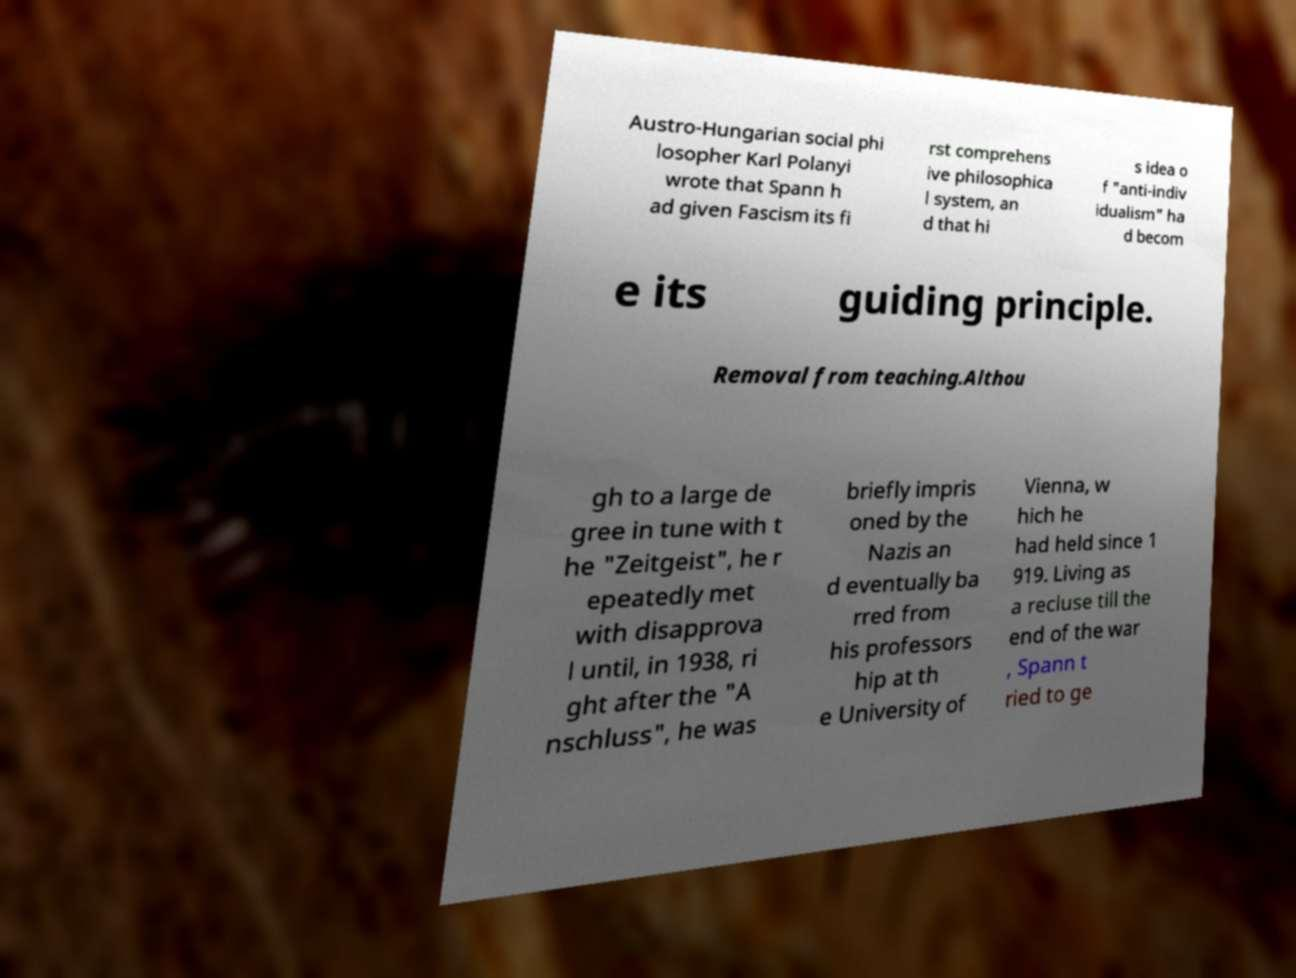There's text embedded in this image that I need extracted. Can you transcribe it verbatim? Austro-Hungarian social phi losopher Karl Polanyi wrote that Spann h ad given Fascism its fi rst comprehens ive philosophica l system, an d that hi s idea o f "anti-indiv idualism" ha d becom e its guiding principle. Removal from teaching.Althou gh to a large de gree in tune with t he "Zeitgeist", he r epeatedly met with disapprova l until, in 1938, ri ght after the "A nschluss", he was briefly impris oned by the Nazis an d eventually ba rred from his professors hip at th e University of Vienna, w hich he had held since 1 919. Living as a recluse till the end of the war , Spann t ried to ge 